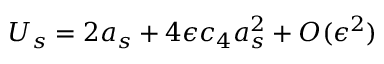Convert formula to latex. <formula><loc_0><loc_0><loc_500><loc_500>U _ { s } = 2 a _ { s } + 4 \epsilon c _ { 4 } a _ { s } ^ { 2 } + O ( \epsilon ^ { 2 } )</formula> 